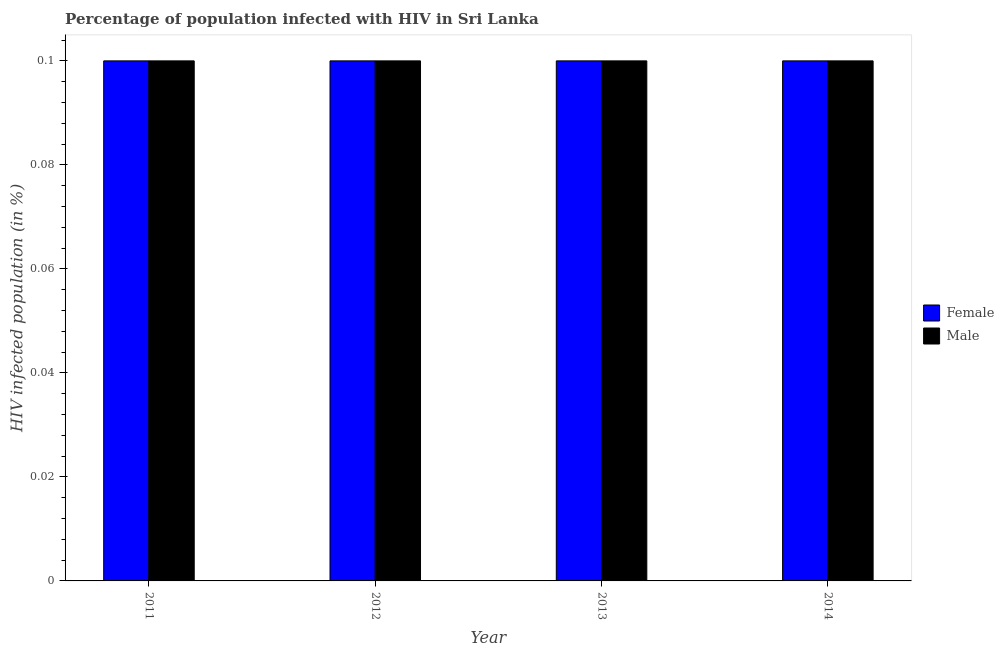How many different coloured bars are there?
Your answer should be very brief. 2. How many groups of bars are there?
Ensure brevity in your answer.  4. How many bars are there on the 4th tick from the left?
Provide a short and direct response. 2. In how many cases, is the number of bars for a given year not equal to the number of legend labels?
Your answer should be very brief. 0. In which year was the percentage of males who are infected with hiv maximum?
Make the answer very short. 2011. In which year was the percentage of males who are infected with hiv minimum?
Give a very brief answer. 2011. What is the total percentage of females who are infected with hiv in the graph?
Your answer should be very brief. 0.4. What is the difference between the percentage of males who are infected with hiv in 2012 and the percentage of females who are infected with hiv in 2011?
Keep it short and to the point. 0. What is the ratio of the percentage of males who are infected with hiv in 2012 to that in 2014?
Provide a short and direct response. 1. Is the percentage of females who are infected with hiv in 2012 less than that in 2013?
Offer a very short reply. No. What is the difference between the highest and the lowest percentage of males who are infected with hiv?
Provide a short and direct response. 0. Are all the bars in the graph horizontal?
Offer a very short reply. No. How many years are there in the graph?
Your answer should be compact. 4. Are the values on the major ticks of Y-axis written in scientific E-notation?
Offer a very short reply. No. Does the graph contain any zero values?
Give a very brief answer. No. How are the legend labels stacked?
Your answer should be very brief. Vertical. What is the title of the graph?
Offer a terse response. Percentage of population infected with HIV in Sri Lanka. What is the label or title of the Y-axis?
Ensure brevity in your answer.  HIV infected population (in %). What is the HIV infected population (in %) of Male in 2011?
Your answer should be compact. 0.1. What is the HIV infected population (in %) in Male in 2012?
Offer a terse response. 0.1. What is the HIV infected population (in %) of Female in 2013?
Offer a terse response. 0.1. What is the HIV infected population (in %) of Female in 2014?
Your answer should be compact. 0.1. Across all years, what is the maximum HIV infected population (in %) in Male?
Your response must be concise. 0.1. What is the total HIV infected population (in %) in Female in the graph?
Your response must be concise. 0.4. What is the difference between the HIV infected population (in %) of Female in 2011 and that in 2013?
Give a very brief answer. 0. What is the difference between the HIV infected population (in %) of Female in 2011 and that in 2014?
Provide a succinct answer. 0. What is the difference between the HIV infected population (in %) of Female in 2012 and that in 2013?
Make the answer very short. 0. What is the difference between the HIV infected population (in %) in Male in 2012 and that in 2013?
Your response must be concise. 0. What is the difference between the HIV infected population (in %) in Male in 2012 and that in 2014?
Provide a succinct answer. 0. What is the difference between the HIV infected population (in %) in Female in 2013 and that in 2014?
Your answer should be compact. 0. What is the difference between the HIV infected population (in %) in Male in 2013 and that in 2014?
Keep it short and to the point. 0. What is the difference between the HIV infected population (in %) of Female in 2011 and the HIV infected population (in %) of Male in 2013?
Provide a short and direct response. 0. What is the difference between the HIV infected population (in %) of Female in 2011 and the HIV infected population (in %) of Male in 2014?
Your answer should be very brief. 0. What is the difference between the HIV infected population (in %) in Female in 2012 and the HIV infected population (in %) in Male in 2013?
Provide a succinct answer. 0. What is the difference between the HIV infected population (in %) in Female in 2013 and the HIV infected population (in %) in Male in 2014?
Make the answer very short. 0. What is the average HIV infected population (in %) of Female per year?
Your response must be concise. 0.1. In the year 2012, what is the difference between the HIV infected population (in %) in Female and HIV infected population (in %) in Male?
Make the answer very short. 0. What is the ratio of the HIV infected population (in %) of Female in 2011 to that in 2013?
Provide a short and direct response. 1. What is the ratio of the HIV infected population (in %) in Male in 2011 to that in 2014?
Ensure brevity in your answer.  1. What is the ratio of the HIV infected population (in %) of Female in 2012 to that in 2013?
Offer a terse response. 1. What is the ratio of the HIV infected population (in %) in Female in 2012 to that in 2014?
Your response must be concise. 1. What is the ratio of the HIV infected population (in %) in Female in 2013 to that in 2014?
Keep it short and to the point. 1. What is the ratio of the HIV infected population (in %) of Male in 2013 to that in 2014?
Your response must be concise. 1. What is the difference between the highest and the second highest HIV infected population (in %) in Male?
Make the answer very short. 0. What is the difference between the highest and the lowest HIV infected population (in %) in Male?
Your answer should be very brief. 0. 